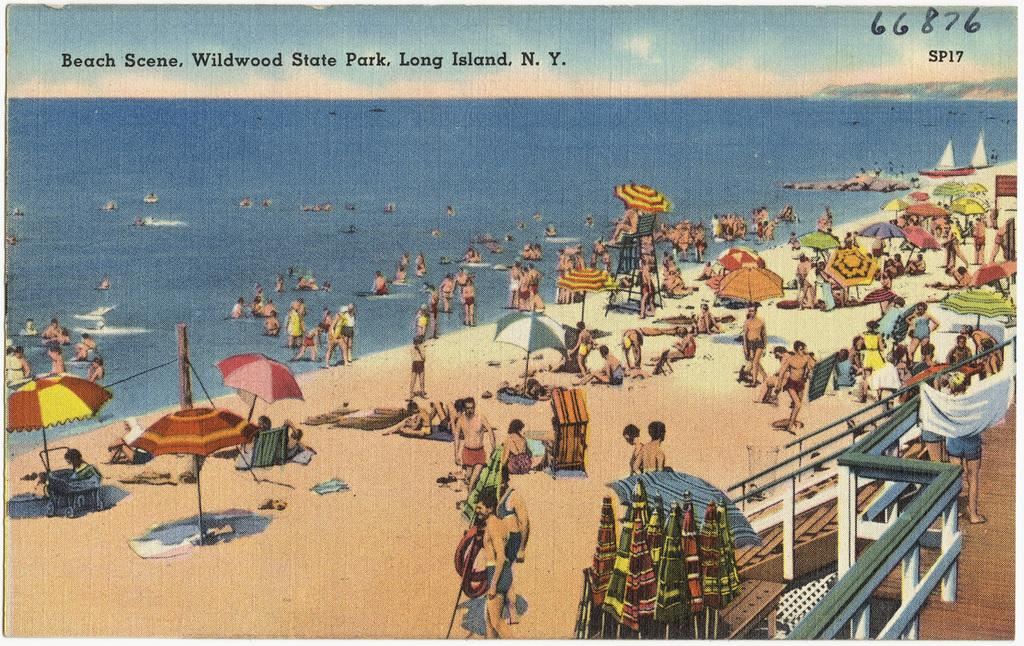<image>
Give a short and clear explanation of the subsequent image. a beach scene, wildwood state park, long island, N. Y. 